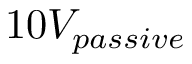Convert formula to latex. <formula><loc_0><loc_0><loc_500><loc_500>1 0 V _ { p a s s i v e }</formula> 